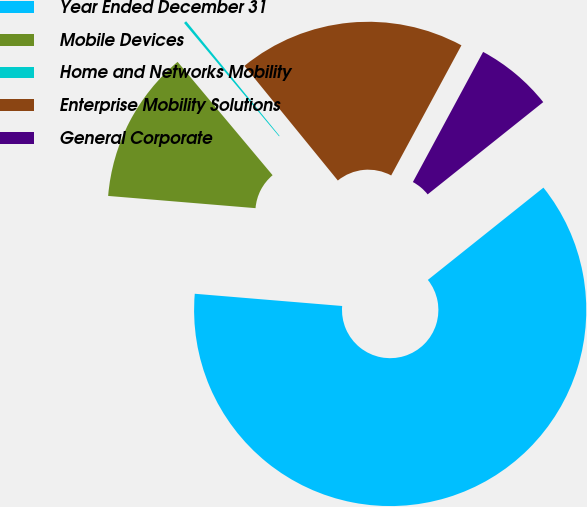<chart> <loc_0><loc_0><loc_500><loc_500><pie_chart><fcel>Year Ended December 31<fcel>Mobile Devices<fcel>Home and Networks Mobility<fcel>Enterprise Mobility Solutions<fcel>General Corporate<nl><fcel>62.04%<fcel>12.58%<fcel>0.22%<fcel>18.76%<fcel>6.4%<nl></chart> 